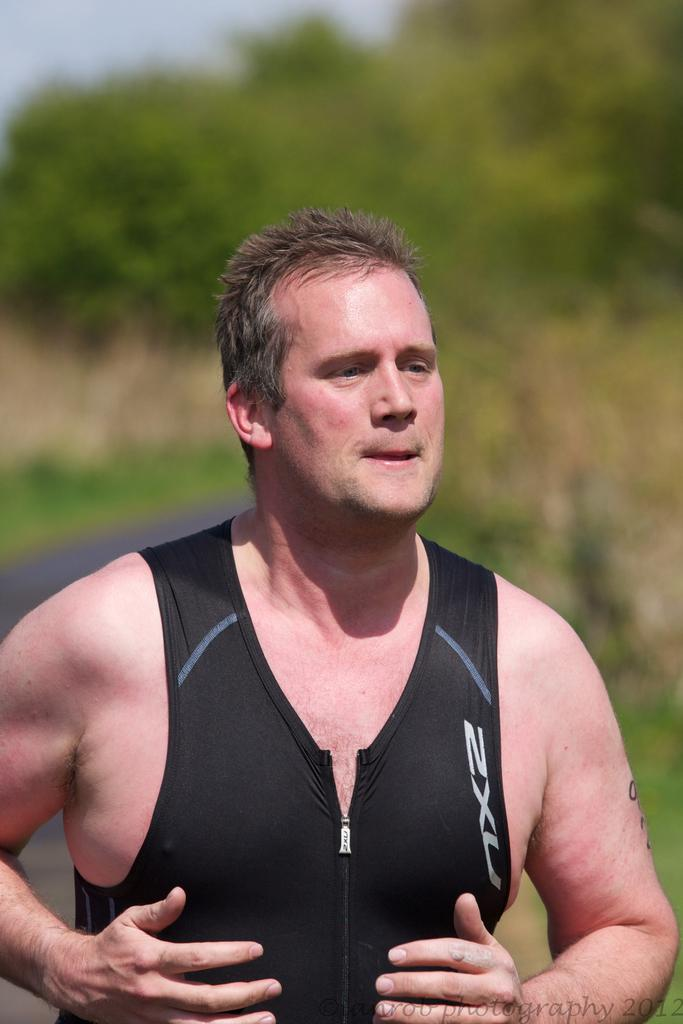<image>
Create a compact narrative representing the image presented. A man is outdoors and is wearing a black vest that has 2XU on it. 